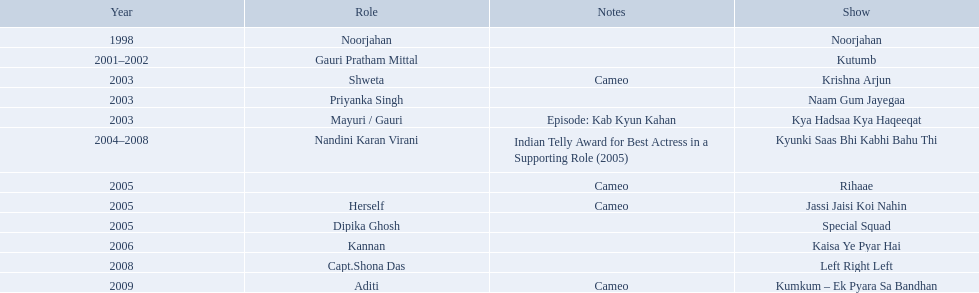What shows was gauri tejwani in? Noorjahan, Kutumb, Krishna Arjun, Naam Gum Jayegaa, Kya Hadsaa Kya Haqeeqat, Kyunki Saas Bhi Kabhi Bahu Thi, Rihaae, Jassi Jaisi Koi Nahin, Special Squad, Kaisa Ye Pyar Hai, Left Right Left, Kumkum – Ek Pyara Sa Bandhan. What were the 2005 shows? Rihaae, Jassi Jaisi Koi Nahin, Special Squad. Which were cameos? Rihaae, Jassi Jaisi Koi Nahin. Of which of these it was not rihaee? Jassi Jaisi Koi Nahin. 